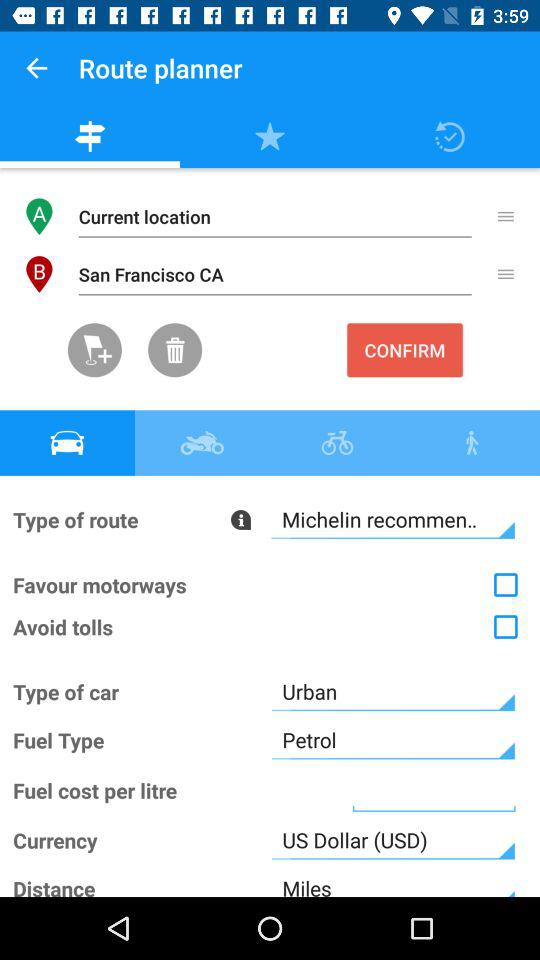What is the fuel type? The fuel type is petrol. 